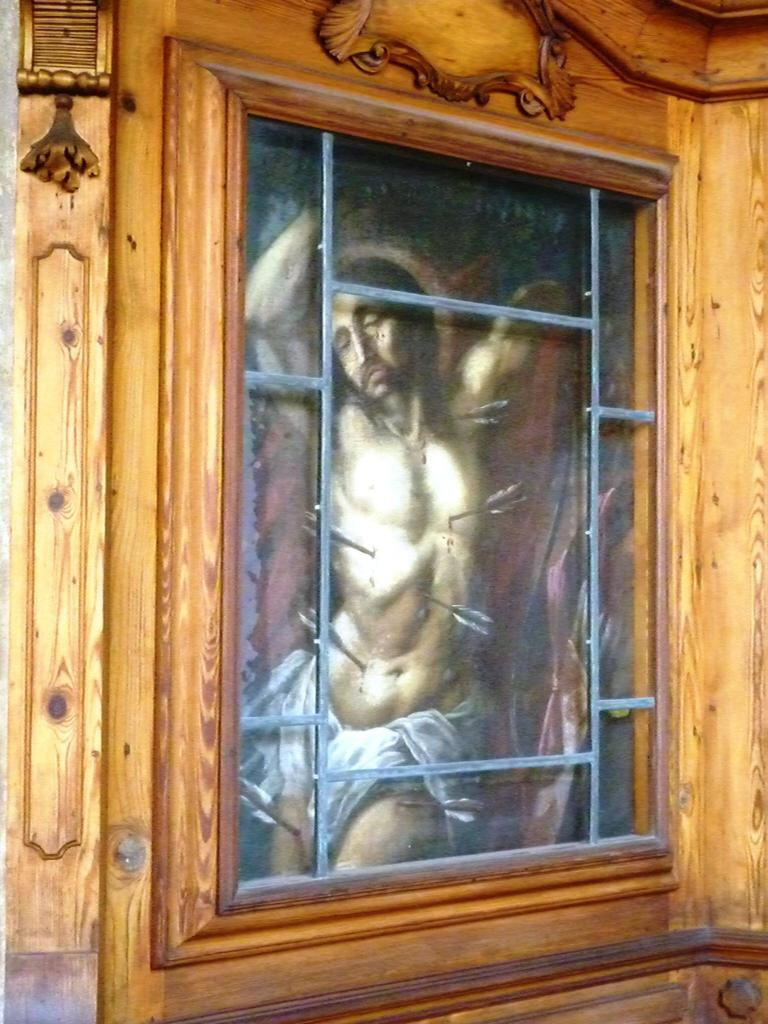What is the color and material of the structure surrounding the photograph? The structure is brown and made of wood. What is depicted in the photograph? The photograph contains a person. What is the person wearing in the photograph? The person is wearing white-colored cloth. How many cakes are being held by the person in the photograph? There are no cakes visible in the photograph; the person is wearing white-colored cloth. 